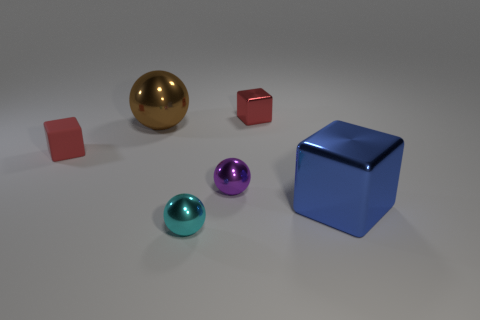There is a big brown thing that is made of the same material as the blue block; what is its shape?
Provide a succinct answer. Sphere. There is a small red thing in front of the red metallic cube; is its shape the same as the big object on the left side of the small cyan object?
Provide a short and direct response. No. There is a brown thing that is the same shape as the small purple metal thing; what is it made of?
Provide a succinct answer. Metal. How many cubes are either blue metallic objects or tiny cyan objects?
Offer a very short reply. 1. What number of other tiny spheres have the same material as the cyan ball?
Give a very brief answer. 1. Are the tiny ball on the right side of the small cyan object and the red object in front of the tiny red metallic object made of the same material?
Provide a short and direct response. No. There is a big blue metallic cube that is behind the small cyan shiny object to the right of the big brown metallic thing; what number of objects are in front of it?
Keep it short and to the point. 1. There is a small metal sphere behind the blue block; does it have the same color as the cube that is in front of the small rubber cube?
Provide a short and direct response. No. Is there any other thing that has the same color as the large ball?
Provide a short and direct response. No. There is a big thing that is on the right side of the large metallic thing behind the matte thing; what is its color?
Keep it short and to the point. Blue. 